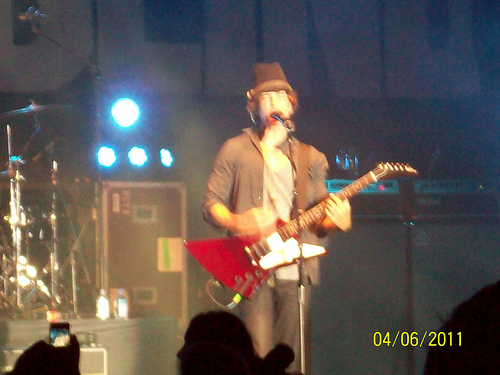<image>
Can you confirm if the man is in front of the drums? No. The man is not in front of the drums. The spatial positioning shows a different relationship between these objects. Is there a hat above the man? No. The hat is not positioned above the man. The vertical arrangement shows a different relationship. 